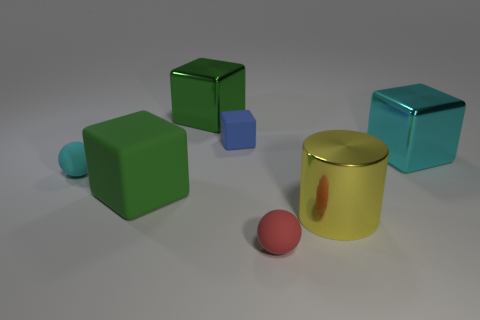Add 1 gray rubber cylinders. How many objects exist? 8 Subtract all cyan blocks. How many blocks are left? 3 Subtract all cyan cubes. How many cubes are left? 3 Subtract 1 blocks. How many blocks are left? 3 Subtract all cubes. How many objects are left? 3 Subtract all red cubes. Subtract all blue balls. How many cubes are left? 4 Subtract 0 yellow blocks. How many objects are left? 7 Subtract all blue matte cubes. Subtract all tiny cyan rubber balls. How many objects are left? 5 Add 5 small blue cubes. How many small blue cubes are left? 6 Add 7 big gray blocks. How many big gray blocks exist? 7 